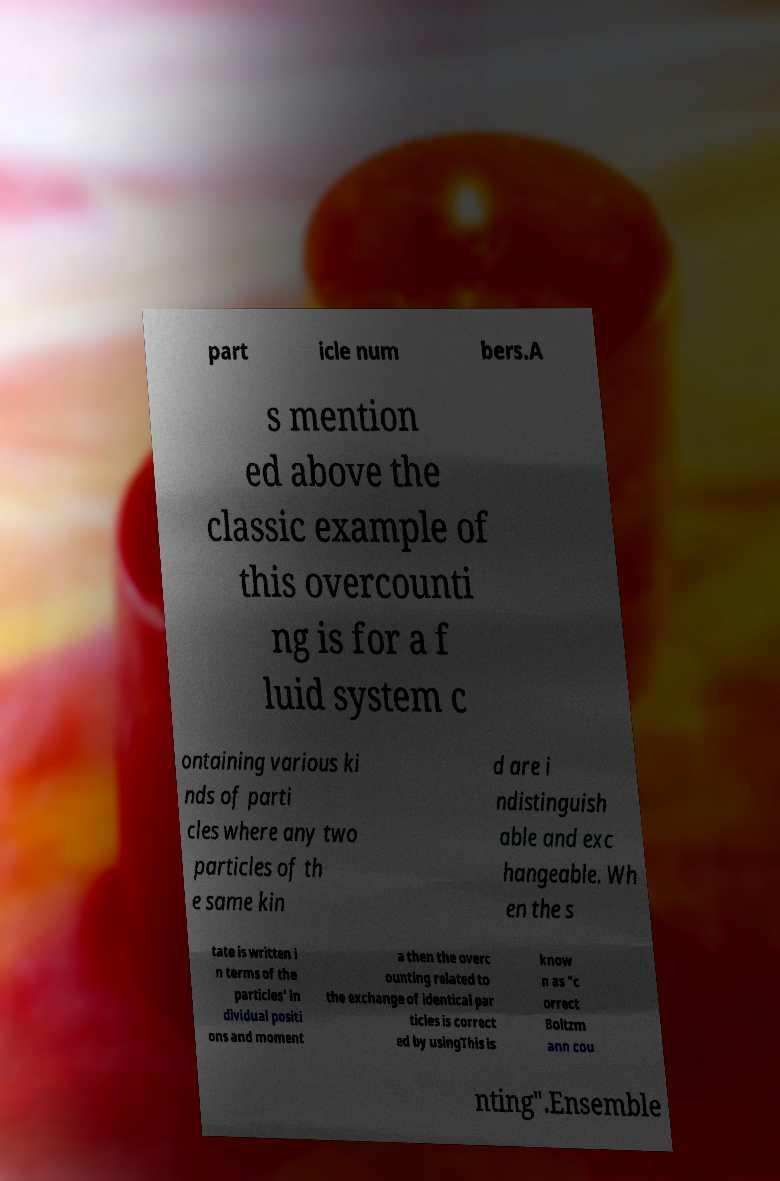What messages or text are displayed in this image? I need them in a readable, typed format. part icle num bers.A s mention ed above the classic example of this overcounti ng is for a f luid system c ontaining various ki nds of parti cles where any two particles of th e same kin d are i ndistinguish able and exc hangeable. Wh en the s tate is written i n terms of the particles' in dividual positi ons and moment a then the overc ounting related to the exchange of identical par ticles is correct ed by usingThis is know n as "c orrect Boltzm ann cou nting".Ensemble 